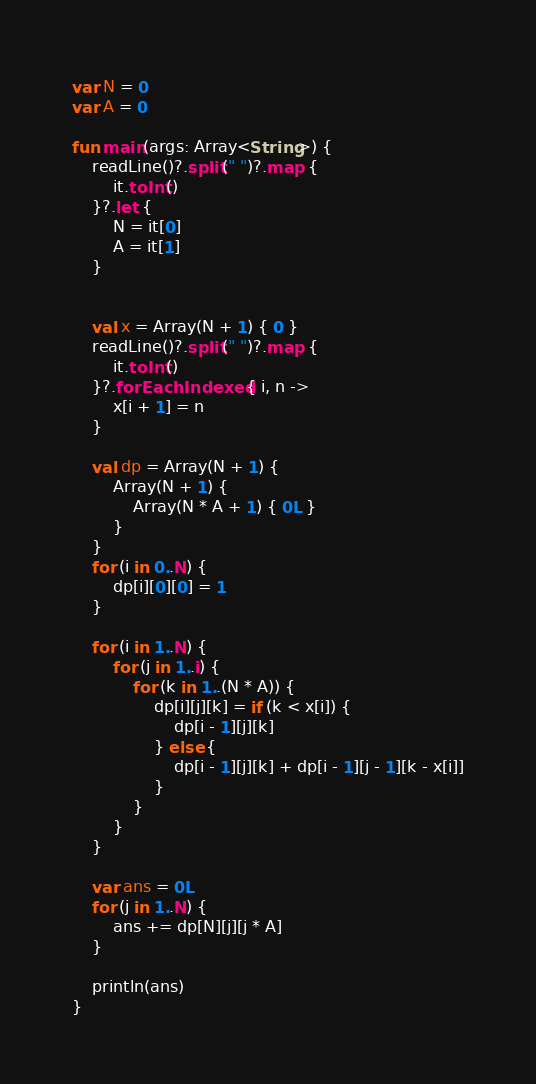<code> <loc_0><loc_0><loc_500><loc_500><_Kotlin_>var N = 0
var A = 0

fun main(args: Array<String>) {
    readLine()?.split(" ")?.map {
        it.toInt()
    }?.let {
        N = it[0]
        A = it[1]
    }


    val x = Array(N + 1) { 0 }
    readLine()?.split(" ")?.map {
        it.toInt()
    }?.forEachIndexed { i, n ->
        x[i + 1] = n
    }

    val dp = Array(N + 1) {
        Array(N + 1) {
            Array(N * A + 1) { 0L }
        }
    }
    for (i in 0..N) {
        dp[i][0][0] = 1
    }

    for (i in 1..N) {
        for (j in 1..i) {
            for (k in 1..(N * A)) {
                dp[i][j][k] = if (k < x[i]) {
                    dp[i - 1][j][k]
                } else {
                    dp[i - 1][j][k] + dp[i - 1][j - 1][k - x[i]]
                }
            }
        }
    }

    var ans = 0L
    for (j in 1..N) {
        ans += dp[N][j][j * A]
    }

    println(ans)
}

</code> 